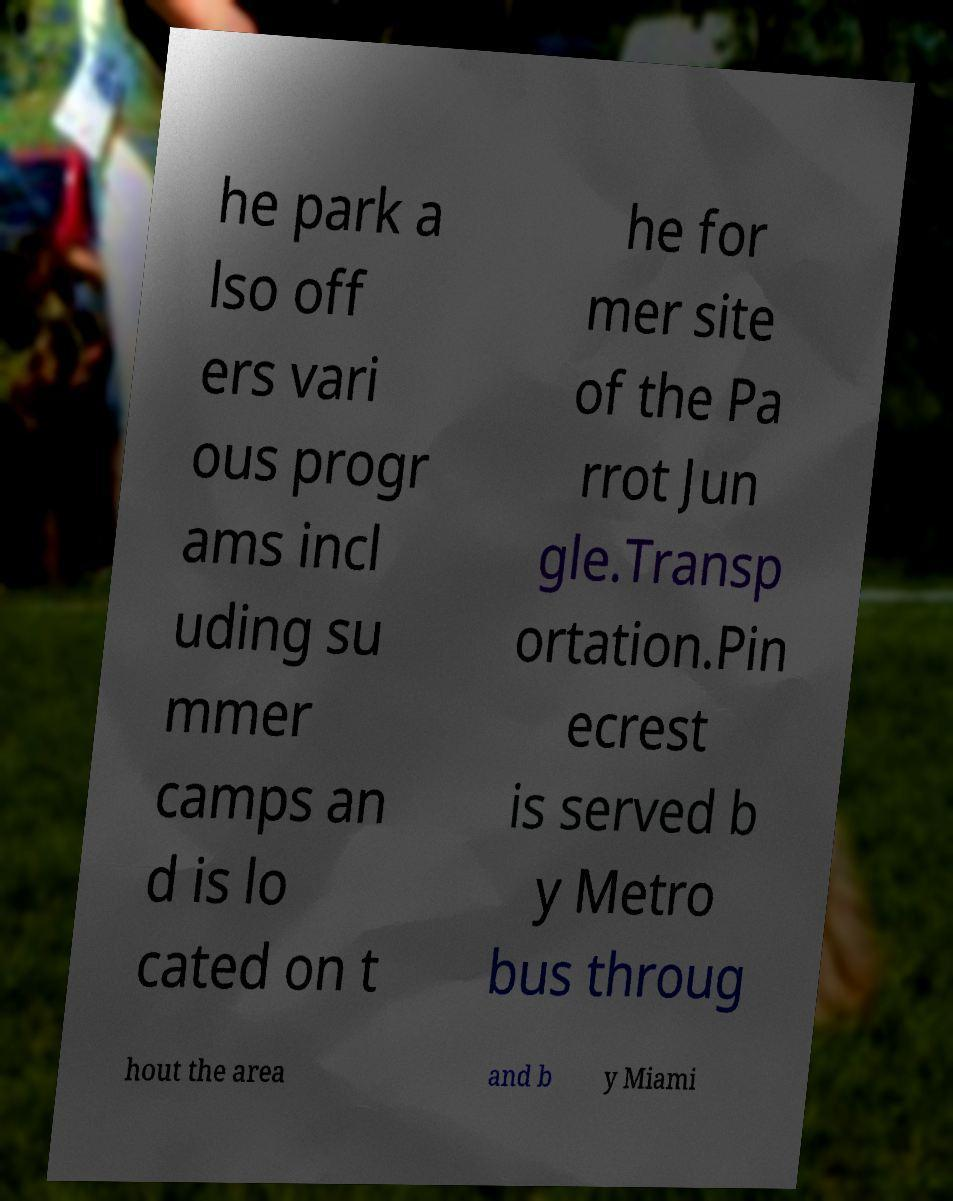Please identify and transcribe the text found in this image. he park a lso off ers vari ous progr ams incl uding su mmer camps an d is lo cated on t he for mer site of the Pa rrot Jun gle.Transp ortation.Pin ecrest is served b y Metro bus throug hout the area and b y Miami 